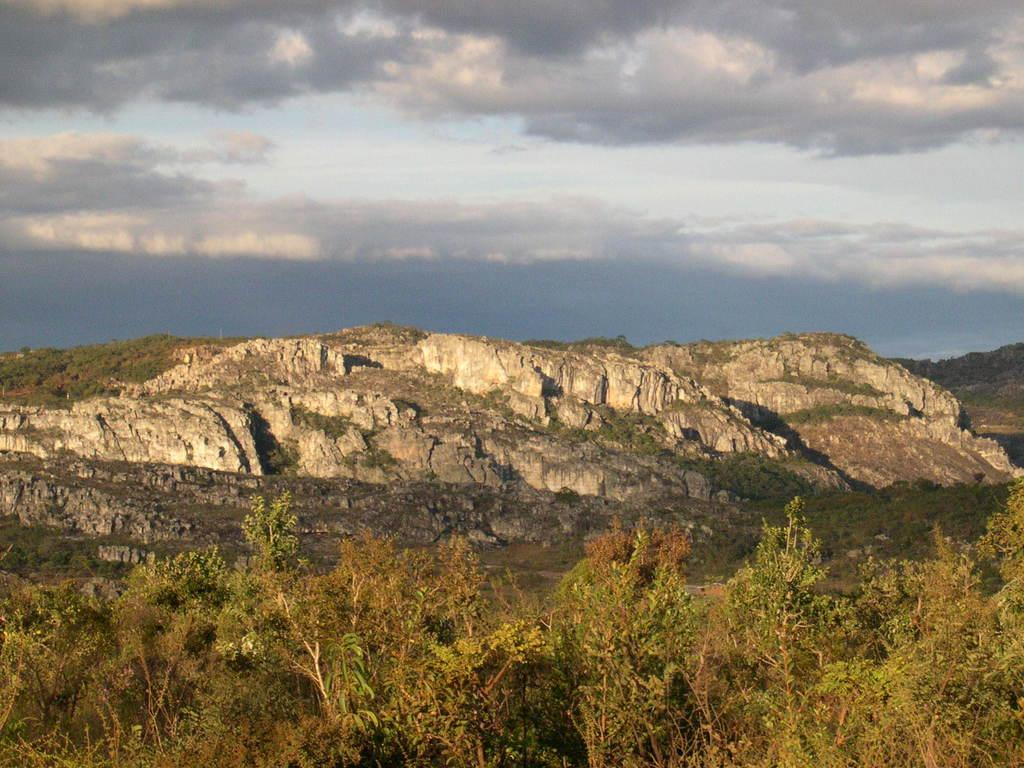What type of natural elements can be seen in the image? There are rocks, trees, and mountains in the image. What is the color of the sky in the image? The sky is blue and white in color. Are there any dinosaurs visible in the image? No, there are no dinosaurs present in the image. What type of health benefits can be gained from sitting on the rocks in the image? There is no mention of rocks being used for sitting or any health benefits in the image. 